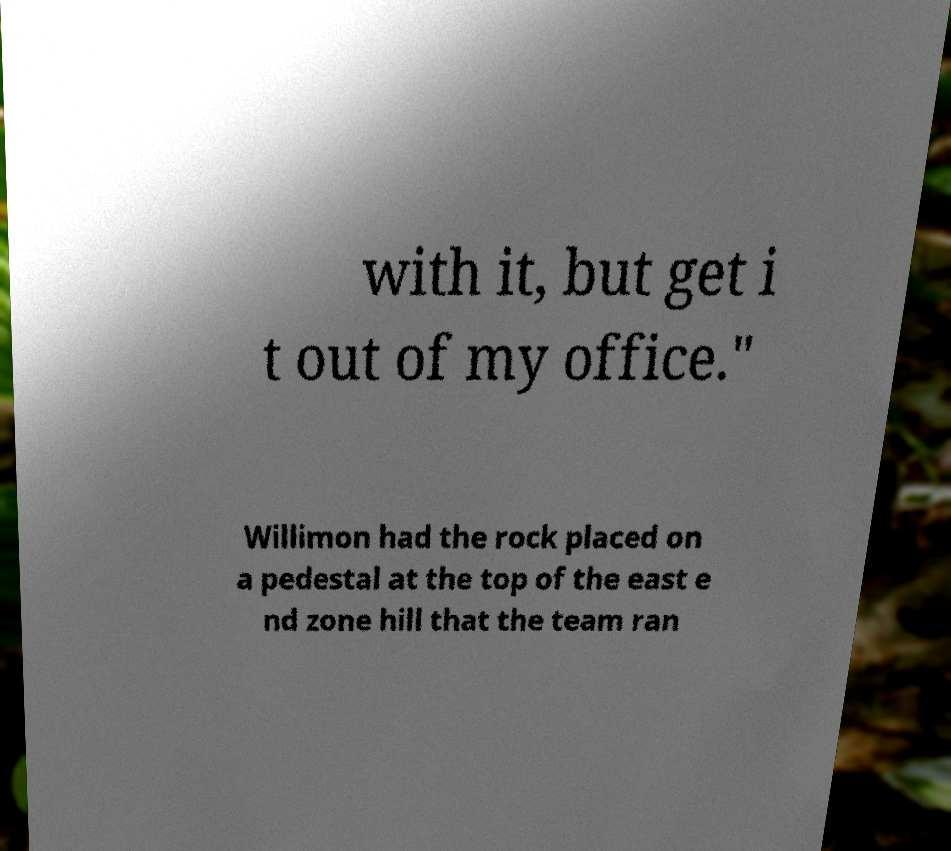Could you assist in decoding the text presented in this image and type it out clearly? with it, but get i t out of my office." Willimon had the rock placed on a pedestal at the top of the east e nd zone hill that the team ran 